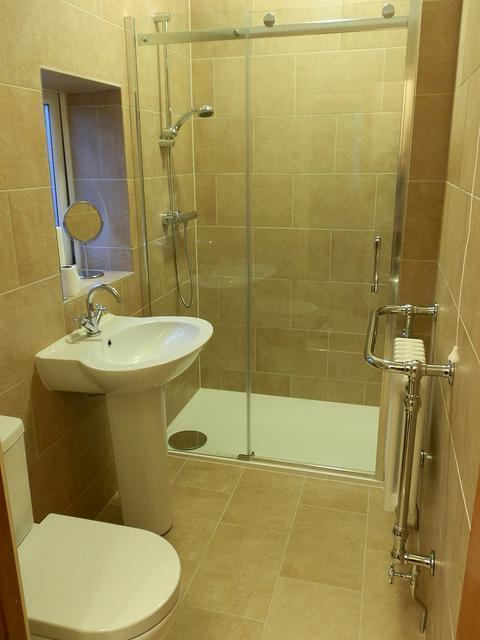How many horses are pulling the carriage?
Give a very brief answer. 0. 